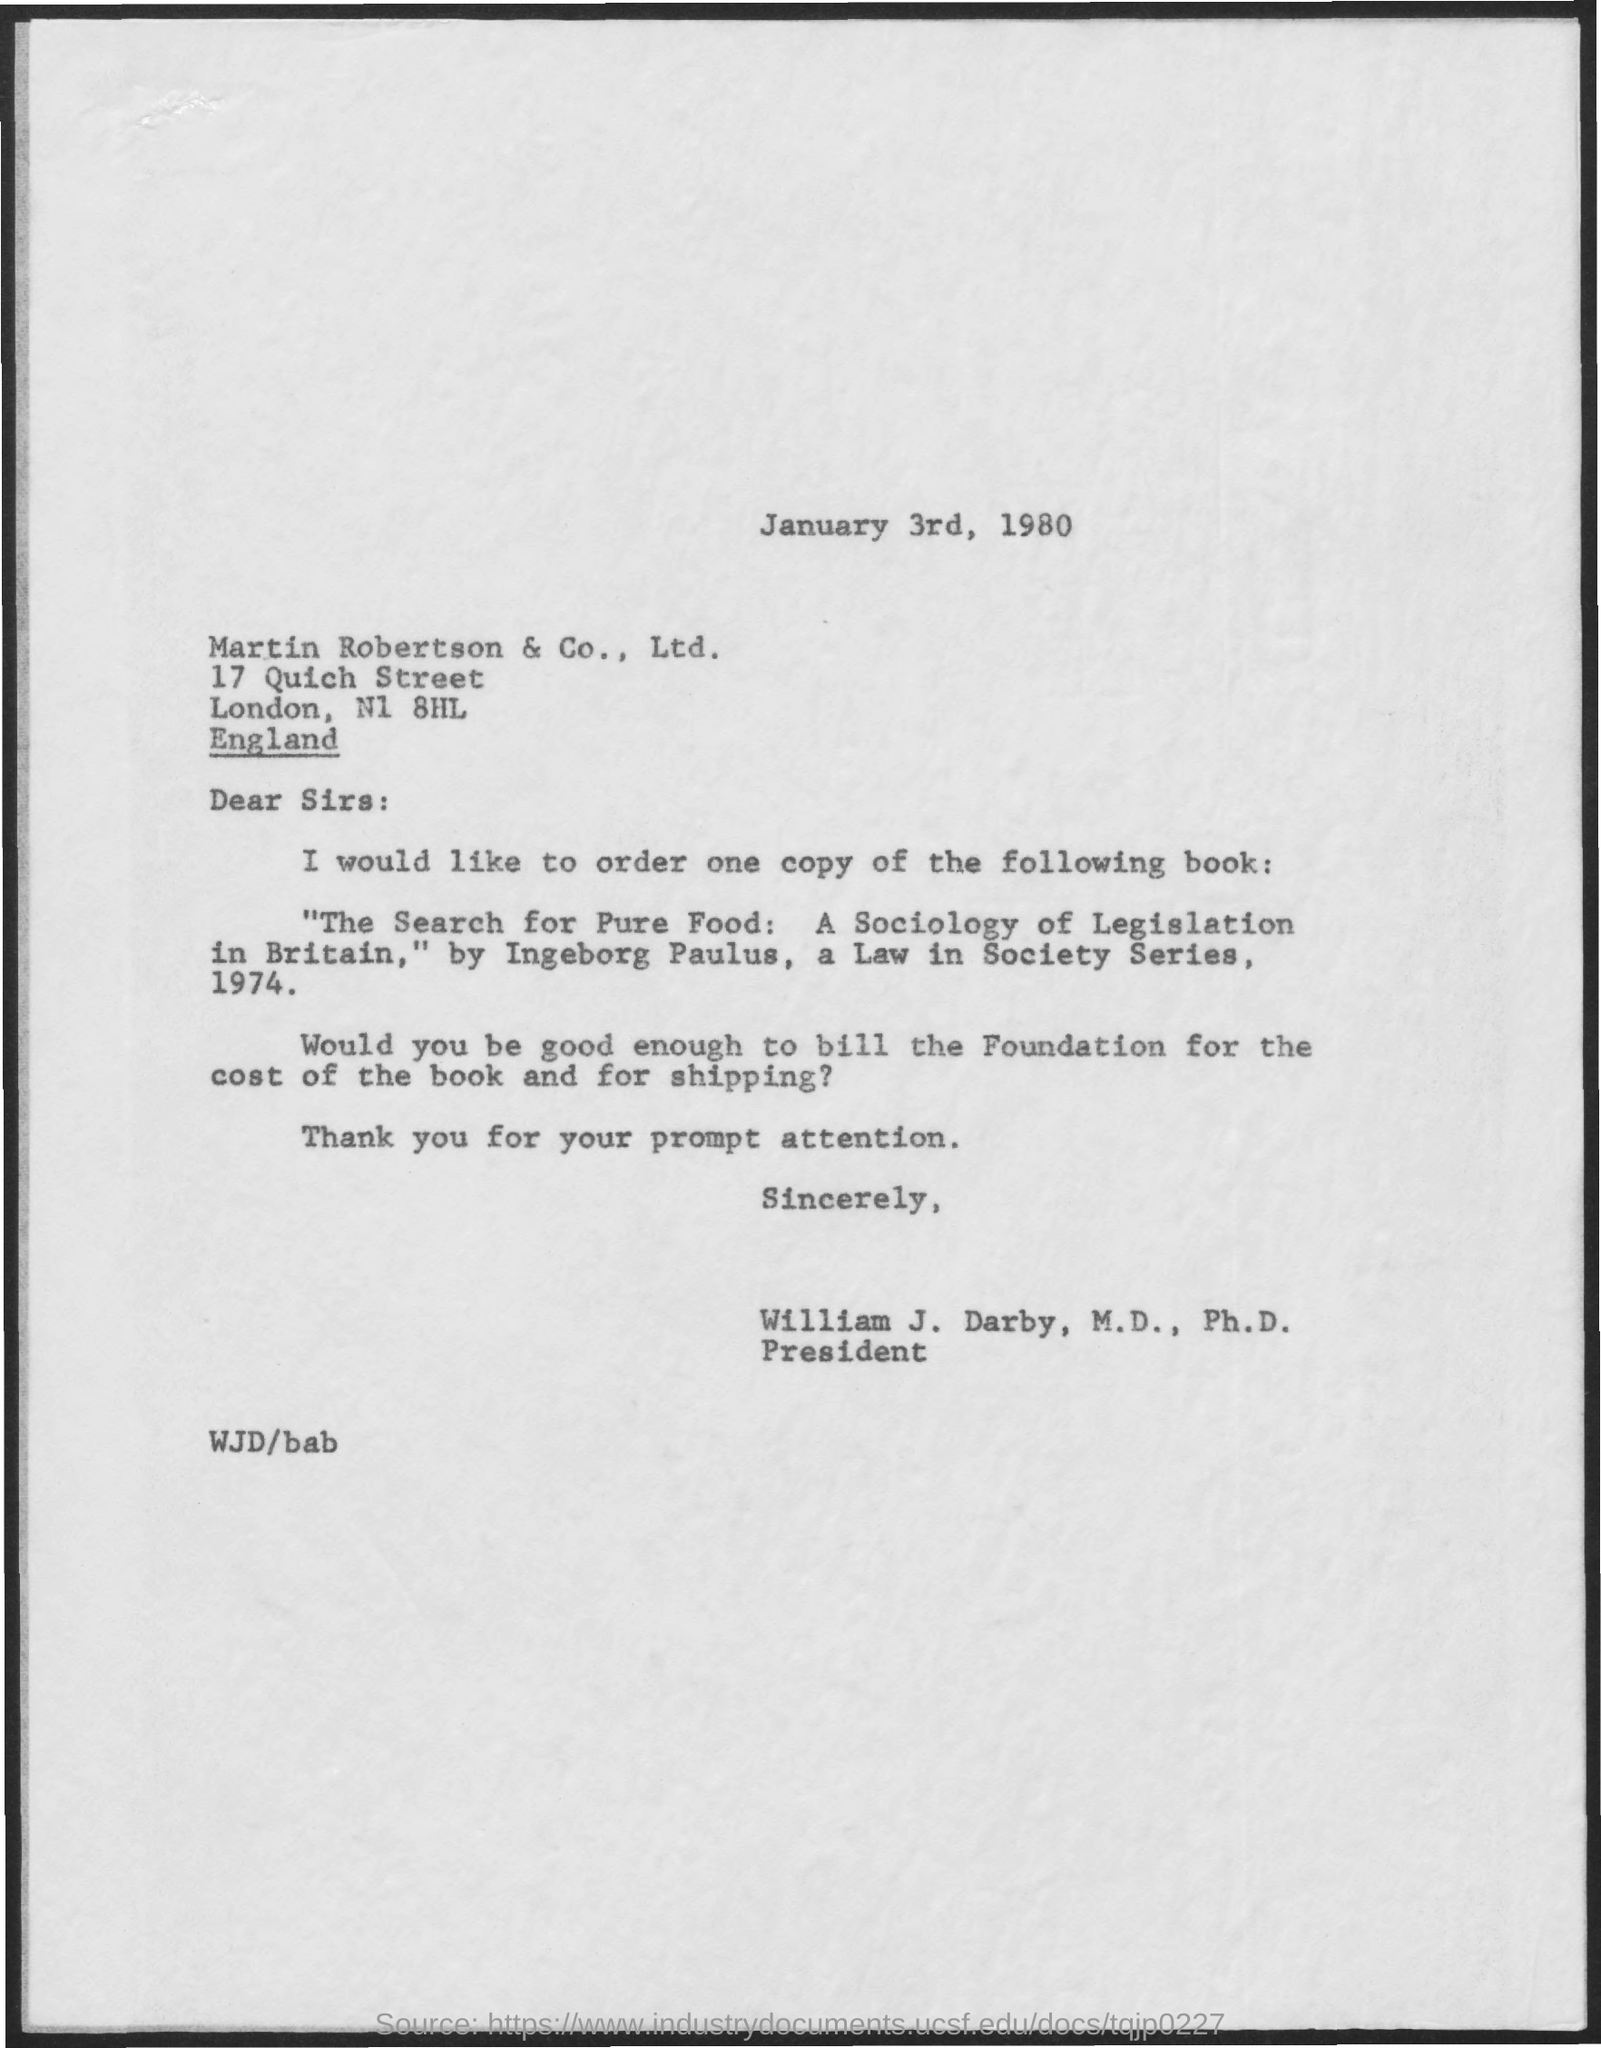What is the date mentioned in this letter?
Keep it short and to the point. January 3rd, 1980. To which company, this letter is addressed?
Ensure brevity in your answer.  Martin Robertson & Co., Ltd. 